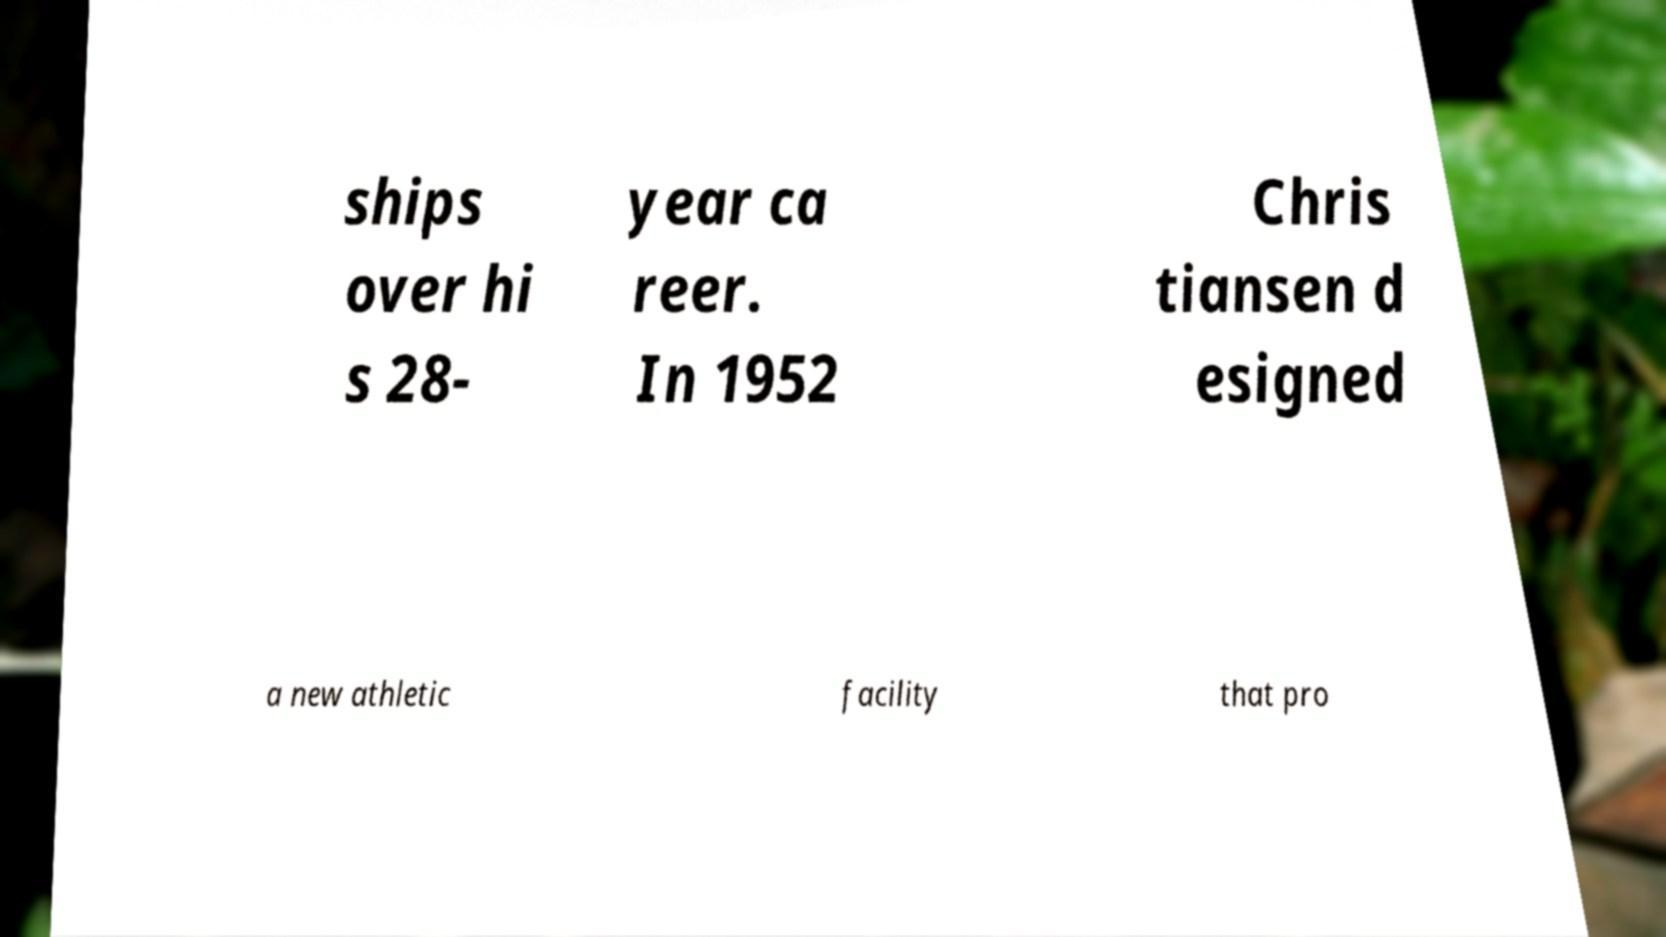Can you read and provide the text displayed in the image?This photo seems to have some interesting text. Can you extract and type it out for me? ships over hi s 28- year ca reer. In 1952 Chris tiansen d esigned a new athletic facility that pro 